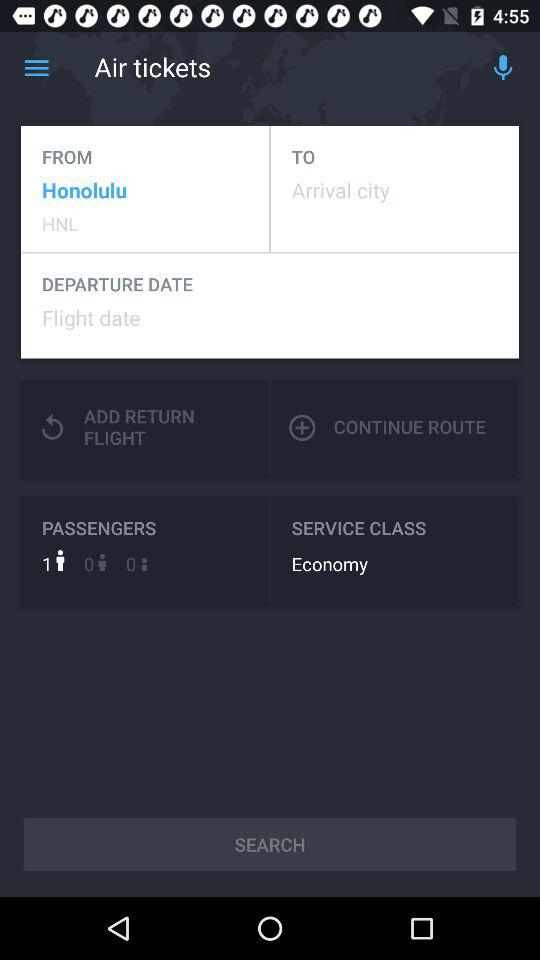Which class does the ticket belong to? The ticket belongs to the economy class. 